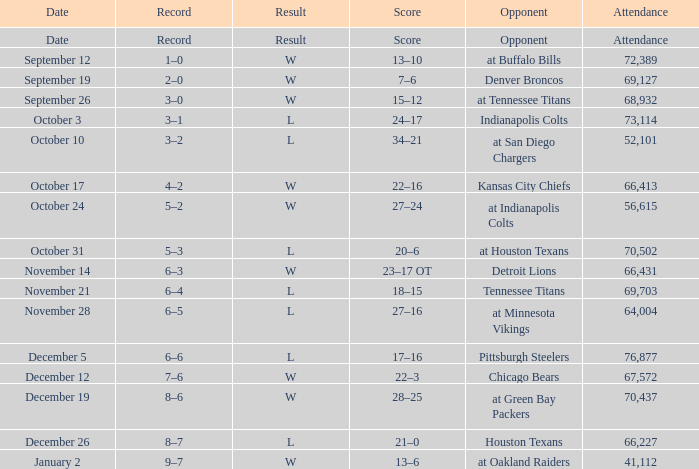What score has October 31 as the date? 20–6. 